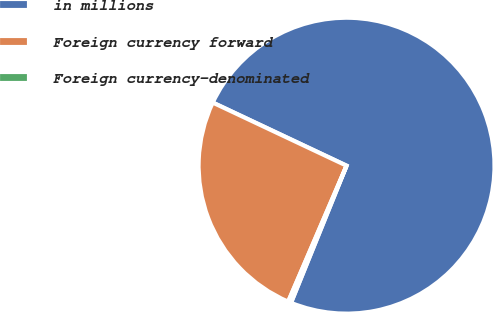Convert chart to OTSL. <chart><loc_0><loc_0><loc_500><loc_500><pie_chart><fcel>in millions<fcel>Foreign currency forward<fcel>Foreign currency-denominated<nl><fcel>74.11%<fcel>25.56%<fcel>0.33%<nl></chart> 